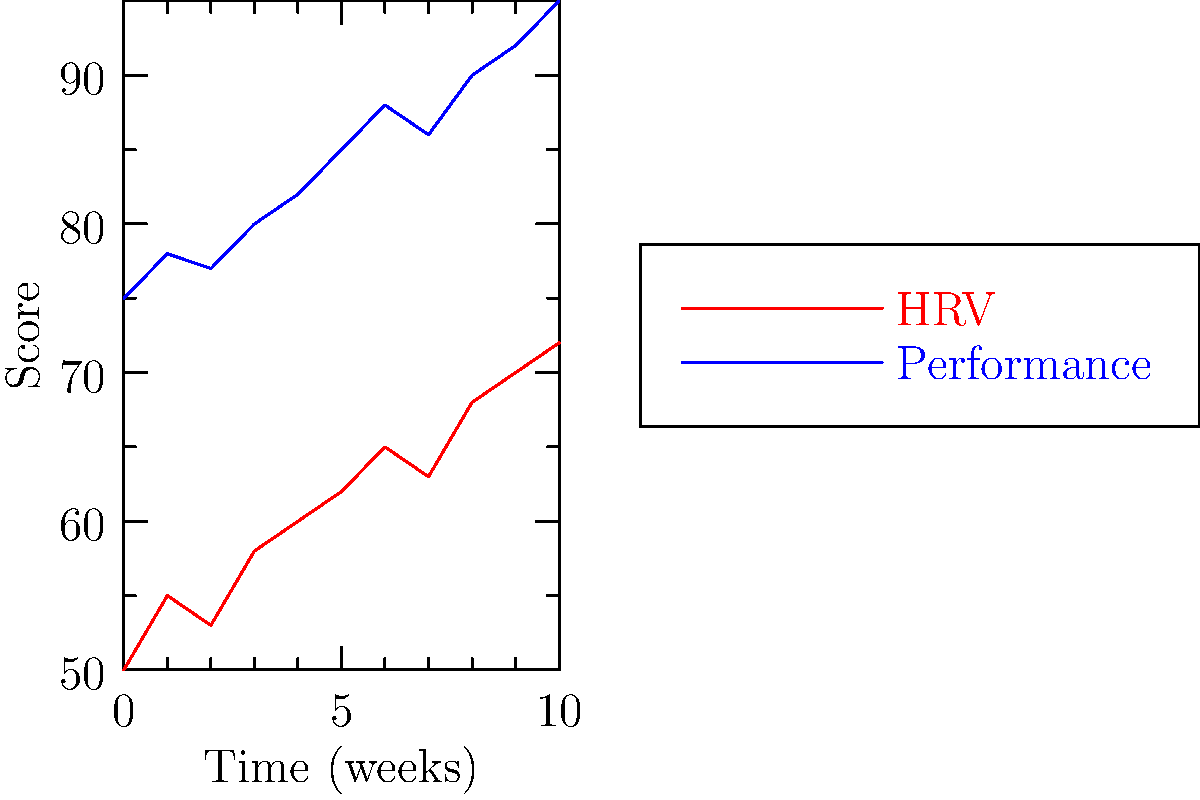As you analyze the time series plot of your friend's heart rate variability (HRV) and athletic performance over 10 weeks, what can you conclude about the relationship between these two variables? How might this information be used to optimize their training regimen? To answer this question, let's analyze the time series plot step-by-step:

1. Observe the general trends:
   - Both HRV (red line) and performance (blue line) show an overall increasing trend over the 10-week period.
   - The increase is not perfectly linear, with some fluctuations in both variables.

2. Examine the correlation:
   - There appears to be a positive correlation between HRV and performance.
   - When HRV increases, performance tends to increase as well, and vice versa.

3. Analyze specific patterns:
   - In weeks 1-2, both HRV and performance increase.
   - In week 3, there's a slight dip in both variables.
   - From weeks 4-7, both variables show a steady increase.
   - In week 8, there's another small dip in both HRV and performance.
   - Weeks 9-10 show a continued increase in both variables.

4. Interpret the relationship:
   - Higher HRV is generally associated with better recovery and readiness to perform.
   - The positive correlation suggests that as your friend's HRV improves, their athletic performance also tends to improve.

5. Implications for training:
   - Monitoring HRV could help optimize training load and recovery.
   - Periods of increased HRV might indicate readiness for more intense training.
   - Drops in HRV could signal the need for additional recovery time.

6. Optimization strategies:
   - Use HRV data to guide training intensity and volume.
   - Implement recovery strategies when HRV shows a declining trend.
   - Gradually increase training load as HRV improves to maximize performance gains.
Answer: Positive correlation between HRV and performance; use HRV to optimize training intensity and recovery. 